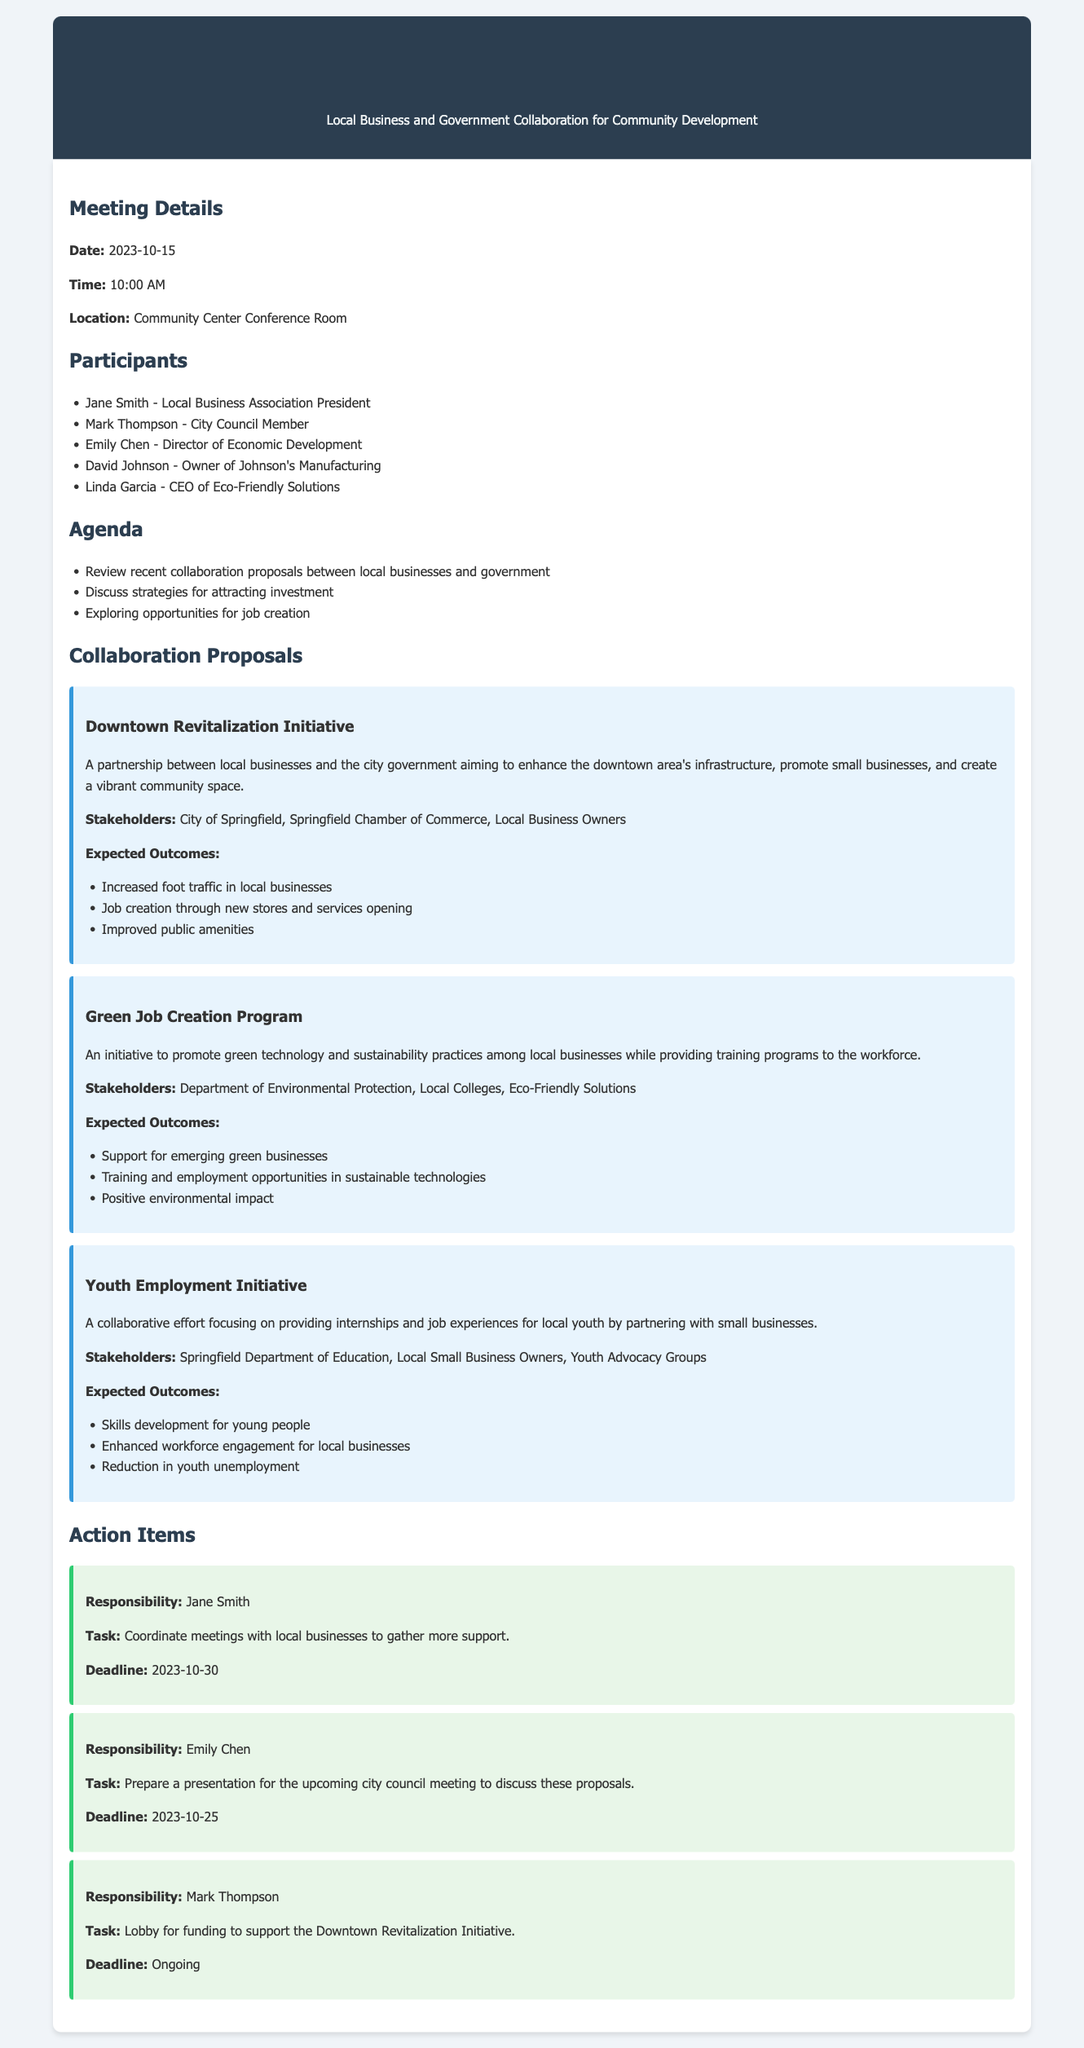what is the meeting date? The meeting date is stated in the document under the Meeting Details section.
Answer: 2023-10-15 who is the CEO of Eco-Friendly Solutions? The participant list includes the names and titles of attendees.
Answer: Linda Garcia what initiative focuses on providing internships for local youth? The collaboration proposals section describes various initiatives, one specifically targeting youth.
Answer: Youth Employment Initiative how many action items are listed in the document? The Action Items section details the tasks assigned, which can be counted.
Answer: 3 what is the deadline for Jane Smith's task? Each action item includes a specific deadline for the assigned tasks.
Answer: 2023-10-30 which stakeholders are involved in the Green Job Creation Program? The proposal for this program lists its stakeholders, which can be found in the document.
Answer: Department of Environmental Protection, Local Colleges, Eco-Friendly Solutions what is the expected outcome of the Downtown Revitalization Initiative? The document outlines expectations associated with each initiative.
Answer: Increased foot traffic in local businesses who is responsible for lobbying for funding? The Action Items section indicates who is responsible for each task.
Answer: Mark Thompson 